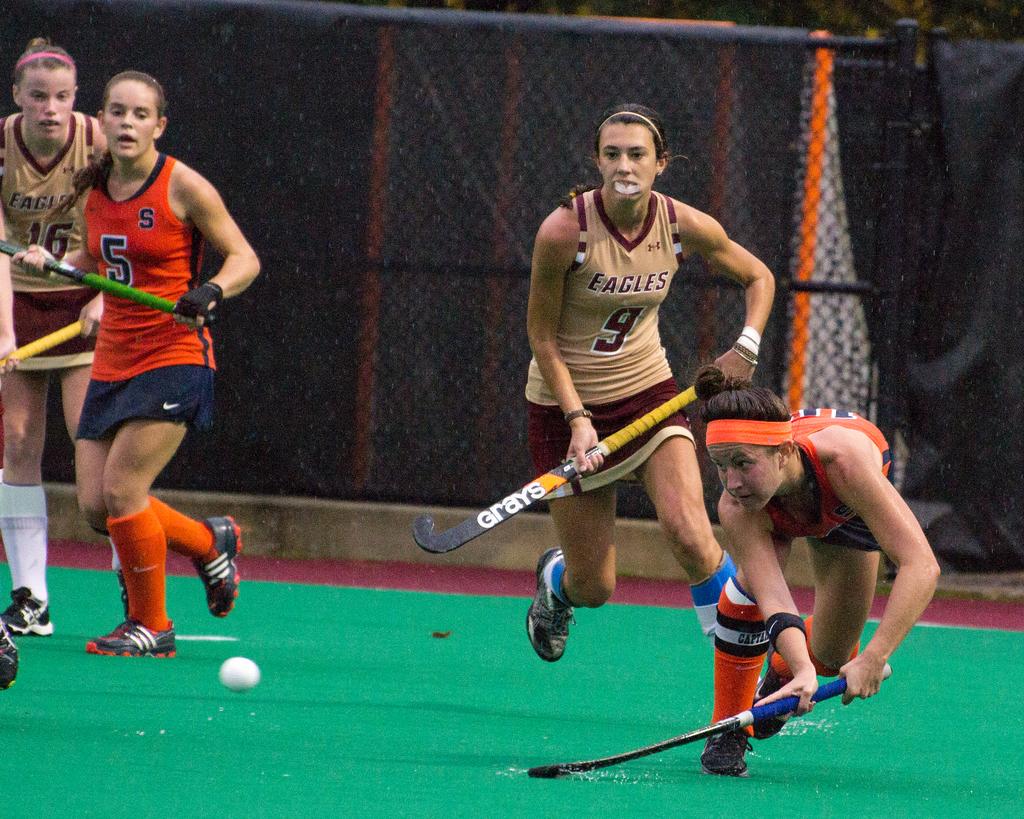What's the number of the player on the right?
Provide a short and direct response. 9. 